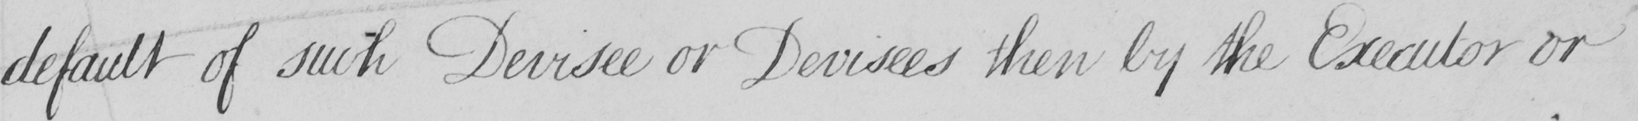What is written in this line of handwriting? default of such Devisee or Devisees then by the Executor or 